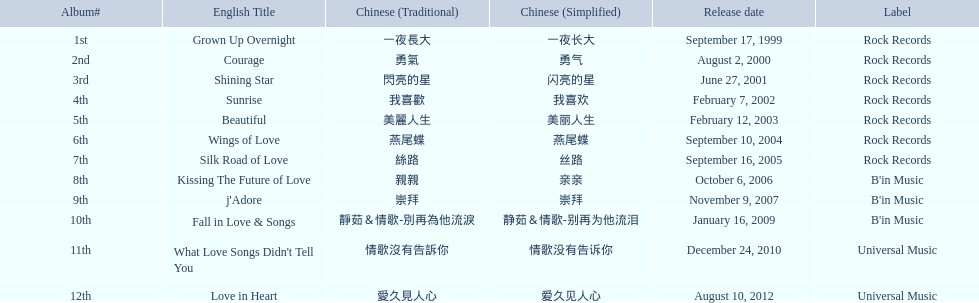What were the albums? Grown Up Overnight, Courage, Shining Star, Sunrise, Beautiful, Wings of Love, Silk Road of Love, Kissing The Future of Love, j'Adore, Fall in Love & Songs, What Love Songs Didn't Tell You, Love in Heart. Which ones were released by b'in music? Kissing The Future of Love, j'Adore. Of these, which one was in an even-numbered year? Kissing The Future of Love. Parse the full table in json format. {'header': ['Album#', 'English Title', 'Chinese (Traditional)', 'Chinese (Simplified)', 'Release date', 'Label'], 'rows': [['1st', 'Grown Up Overnight', '一夜長大', '一夜长大', 'September 17, 1999', 'Rock Records'], ['2nd', 'Courage', '勇氣', '勇气', 'August 2, 2000', 'Rock Records'], ['3rd', 'Shining Star', '閃亮的星', '闪亮的星', 'June 27, 2001', 'Rock Records'], ['4th', 'Sunrise', '我喜歡', '我喜欢', 'February 7, 2002', 'Rock Records'], ['5th', 'Beautiful', '美麗人生', '美丽人生', 'February 12, 2003', 'Rock Records'], ['6th', 'Wings of Love', '燕尾蝶', '燕尾蝶', 'September 10, 2004', 'Rock Records'], ['7th', 'Silk Road of Love', '絲路', '丝路', 'September 16, 2005', 'Rock Records'], ['8th', 'Kissing The Future of Love', '親親', '亲亲', 'October 6, 2006', "B'in Music"], ['9th', "j'Adore", '崇拜', '崇拜', 'November 9, 2007', "B'in Music"], ['10th', 'Fall in Love & Songs', '靜茹＆情歌-別再為他流淚', '静茹＆情歌-别再为他流泪', 'January 16, 2009', "B'in Music"], ['11th', "What Love Songs Didn't Tell You", '情歌沒有告訴你', '情歌没有告诉你', 'December 24, 2010', 'Universal Music'], ['12th', 'Love in Heart', '愛久見人心', '爱久见人心', 'August 10, 2012', 'Universal Music']]} 